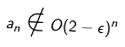Convert formula to latex. <formula><loc_0><loc_0><loc_500><loc_500>a _ { n } \notin O ( 2 - \epsilon ) ^ { n }</formula> 